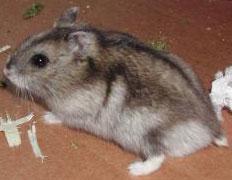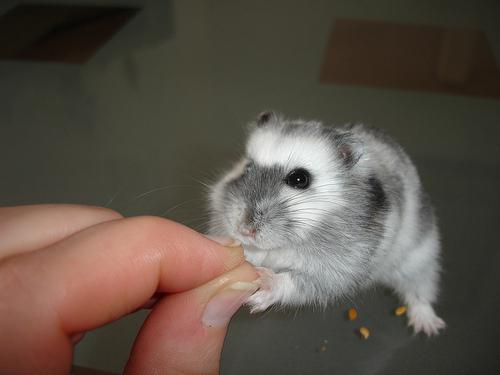The first image is the image on the left, the second image is the image on the right. Analyze the images presented: Is the assertion "Each image contains a single pet rodent, and one of the rodents is held in a pair of upturned hands." valid? Answer yes or no. No. The first image is the image on the left, the second image is the image on the right. For the images shown, is this caption "The right image contains a human touching a rodent." true? Answer yes or no. Yes. 